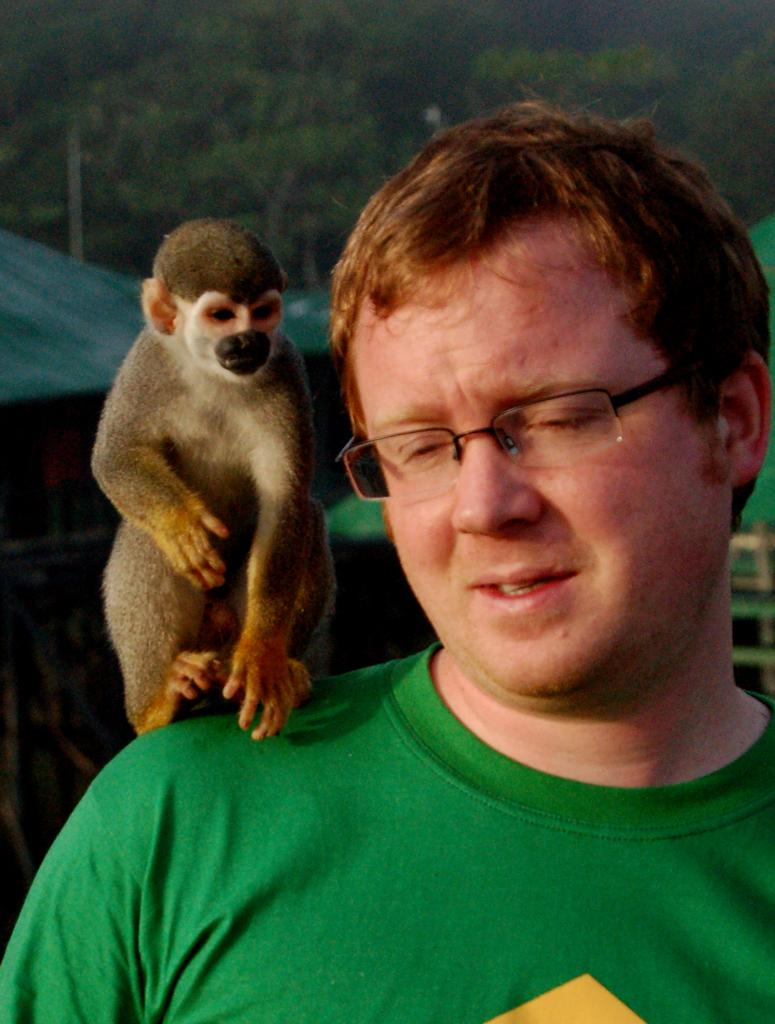Who is present in the image? There is a man in the image. What is the man holding or carrying in the image? The man has a monkey on his shoulders. What can be seen in the background of the image? There are trees, a hit (possibly a hut), and a pole in the background of the image. What type of lettuce is being used as a prop on the stage in the image? There is no stage or lettuce present in the image. What kind of beast is accompanying the man in the image? The man has a monkey on his shoulders, not a beast. 